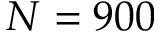<formula> <loc_0><loc_0><loc_500><loc_500>N = 9 0 0</formula> 